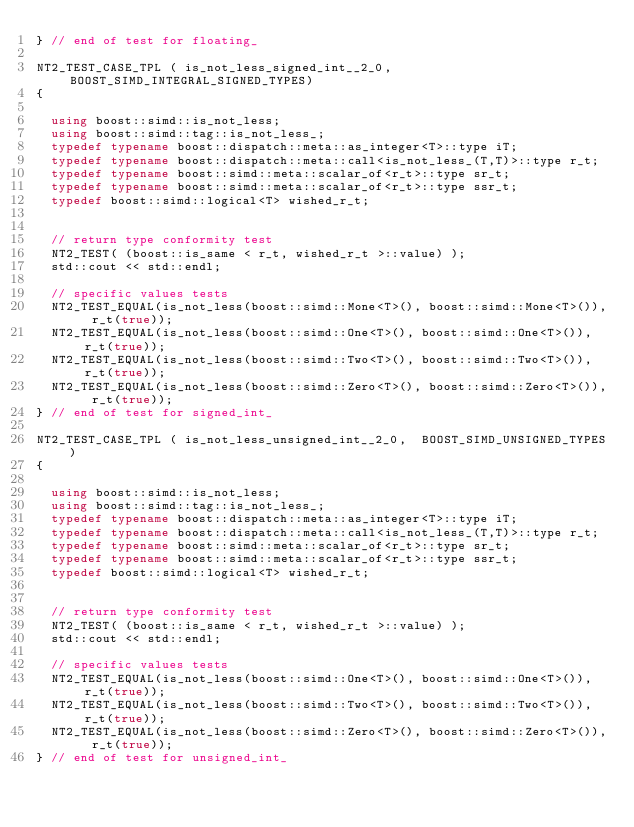Convert code to text. <code><loc_0><loc_0><loc_500><loc_500><_C++_>} // end of test for floating_

NT2_TEST_CASE_TPL ( is_not_less_signed_int__2_0,  BOOST_SIMD_INTEGRAL_SIGNED_TYPES)
{

  using boost::simd::is_not_less;
  using boost::simd::tag::is_not_less_;
  typedef typename boost::dispatch::meta::as_integer<T>::type iT;
  typedef typename boost::dispatch::meta::call<is_not_less_(T,T)>::type r_t;
  typedef typename boost::simd::meta::scalar_of<r_t>::type sr_t;
  typedef typename boost::simd::meta::scalar_of<r_t>::type ssr_t;
  typedef boost::simd::logical<T> wished_r_t;


  // return type conformity test
  NT2_TEST( (boost::is_same < r_t, wished_r_t >::value) );
  std::cout << std::endl;

  // specific values tests
  NT2_TEST_EQUAL(is_not_less(boost::simd::Mone<T>(), boost::simd::Mone<T>()), r_t(true));
  NT2_TEST_EQUAL(is_not_less(boost::simd::One<T>(), boost::simd::One<T>()), r_t(true));
  NT2_TEST_EQUAL(is_not_less(boost::simd::Two<T>(), boost::simd::Two<T>()), r_t(true));
  NT2_TEST_EQUAL(is_not_less(boost::simd::Zero<T>(), boost::simd::Zero<T>()), r_t(true));
} // end of test for signed_int_

NT2_TEST_CASE_TPL ( is_not_less_unsigned_int__2_0,  BOOST_SIMD_UNSIGNED_TYPES)
{

  using boost::simd::is_not_less;
  using boost::simd::tag::is_not_less_;
  typedef typename boost::dispatch::meta::as_integer<T>::type iT;
  typedef typename boost::dispatch::meta::call<is_not_less_(T,T)>::type r_t;
  typedef typename boost::simd::meta::scalar_of<r_t>::type sr_t;
  typedef typename boost::simd::meta::scalar_of<r_t>::type ssr_t;
  typedef boost::simd::logical<T> wished_r_t;


  // return type conformity test
  NT2_TEST( (boost::is_same < r_t, wished_r_t >::value) );
  std::cout << std::endl;

  // specific values tests
  NT2_TEST_EQUAL(is_not_less(boost::simd::One<T>(), boost::simd::One<T>()), r_t(true));
  NT2_TEST_EQUAL(is_not_less(boost::simd::Two<T>(), boost::simd::Two<T>()), r_t(true));
  NT2_TEST_EQUAL(is_not_less(boost::simd::Zero<T>(), boost::simd::Zero<T>()), r_t(true));
} // end of test for unsigned_int_
</code> 